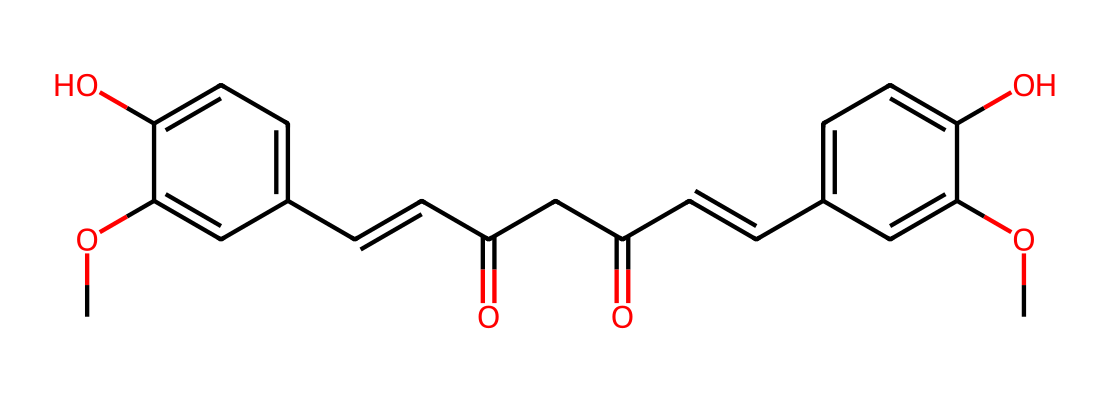What is the primary functional group in curcumin? The presence of the hydroxyl groups (-OH) indicates that the primary functional groups in curcumin are phenolic groups. These are key reactive sites for various interactions.
Answer: phenolic group How many double bonds are present in the molecular structure of curcumin? By analyzing the SMILES representation, we see that there are two instances of "/C=C/", which indicates the presence of two double bonds in the structure.
Answer: 2 What is the molecular weight of curcumin? The molecular weight can be calculated using the number of each type of atom present in the SMILES representation: 21 carbons, 20 hydrogens, and 6 oxygens, leading to a molecular weight of approximately 368.38 g/mol.
Answer: 368.38 g/mol What is the melting point of curcumin? Curcumin has a reported melting point of around 183-186 degrees Celsius, a property that can be referenced in common chemical databases.
Answer: 183-186 °C Does curcumin contain any methoxy groups? The presence of two "O" atoms attached to carbon atoms ("CO" in the SMILES) indicates that there are two methoxy groups (-OCH3) existing in the structure.
Answer: yes What type of polymerization might occur with curcumin? Curcumin can undergo reactions such as oxidation and polymerization involving its phenolic and alkenyl functionalities, which can lead to the formation of more complex compounds under certain conditions.
Answer: oxidative polymerization What potential therapeutic applications does curcumin have based on its structure? The multitude of functional groups in curcumin, particularly the phenolic and the alkenyl structures, suggest potential anti-inflammatory, antioxidant, and anticancer properties, which are observed in traditional herbal medicine practices.
Answer: anti-inflammatory and antioxidant 